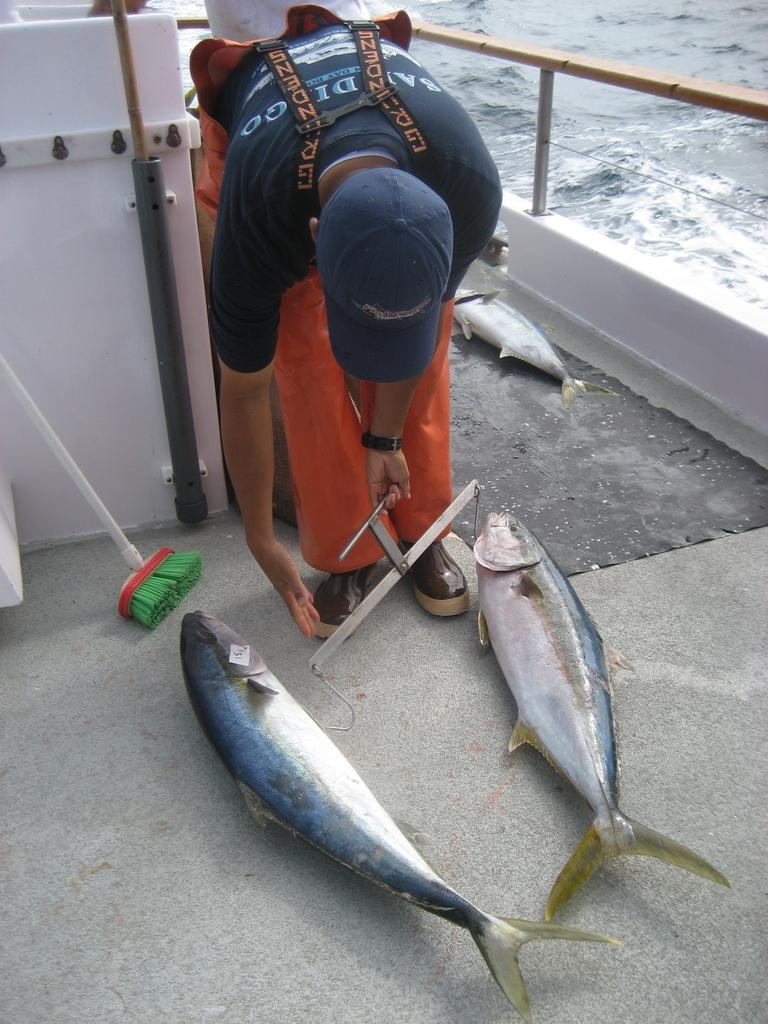Who is present in the image? There is a man in the image. What is the man holding in his hand? The man is holding a metal rod with hooks in his hand. What can be seen in the water in the image? There are fishes visible in the image. What tool is present in the image for cleaning purposes? There is a broom in the image. What mode of transportation is present in the image? There is a boat in the image. What is the primary setting of the image? There is water visible in the image. What type of business is being conducted in the image? There is no indication of a business being conducted in the image. How many cars are visible in the image? There are no cars present in the image. 